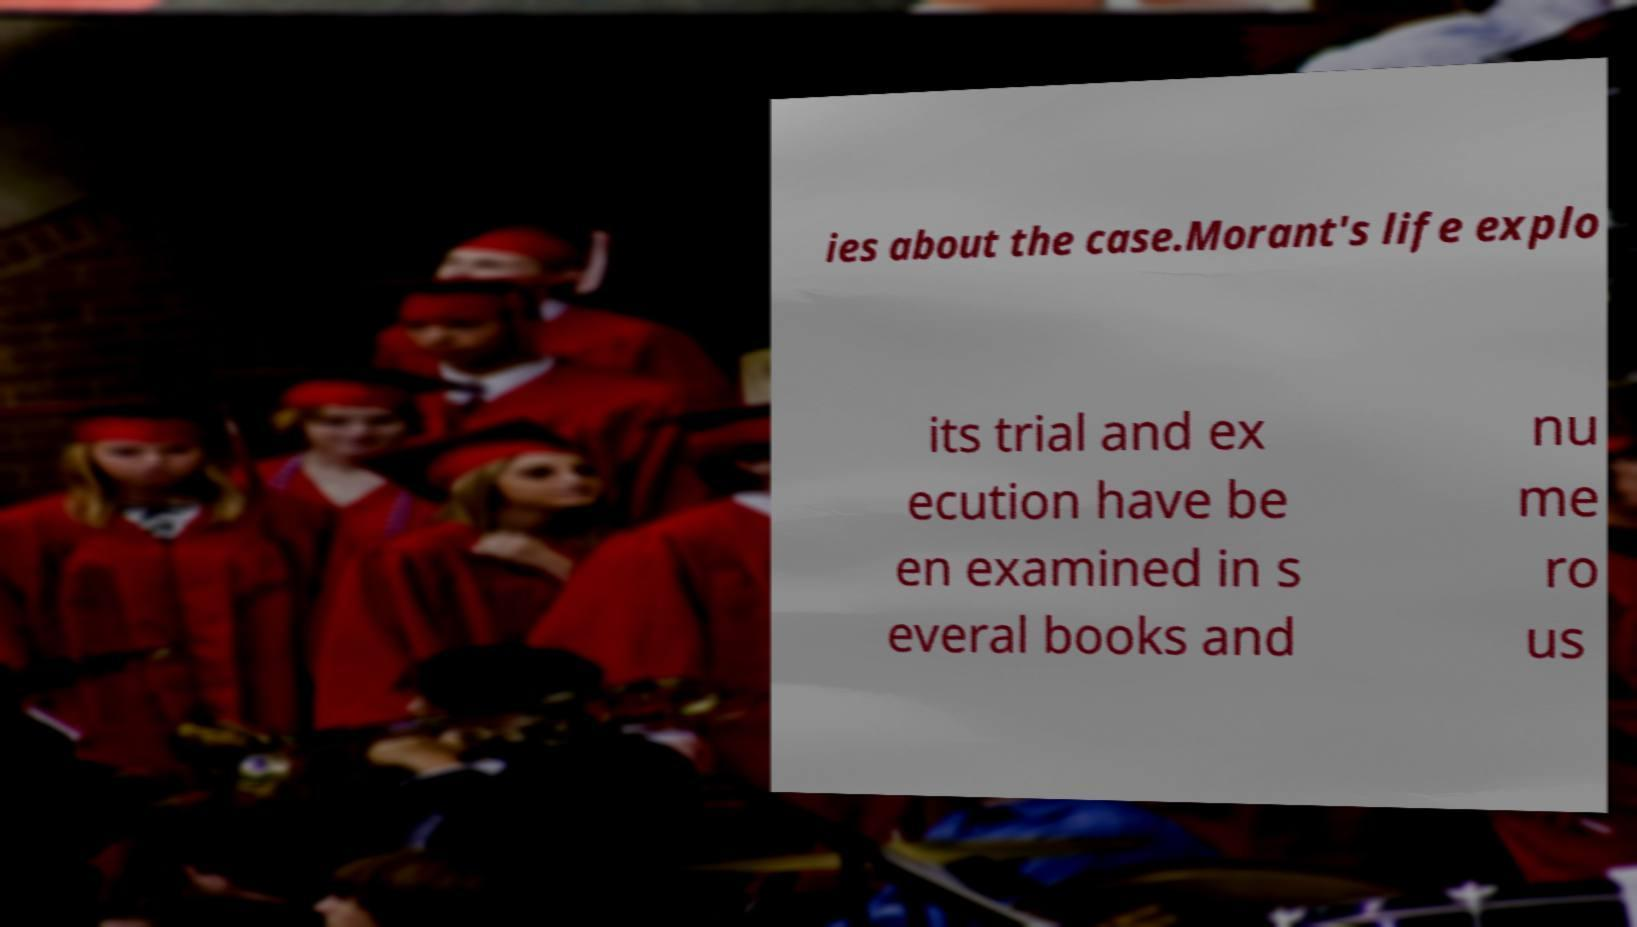I need the written content from this picture converted into text. Can you do that? ies about the case.Morant's life explo its trial and ex ecution have be en examined in s everal books and nu me ro us 